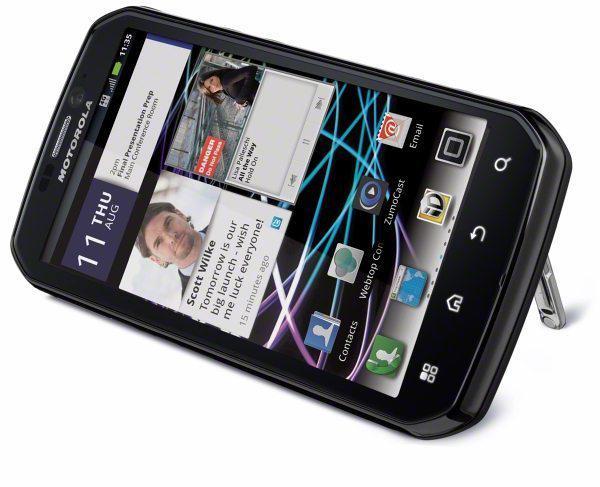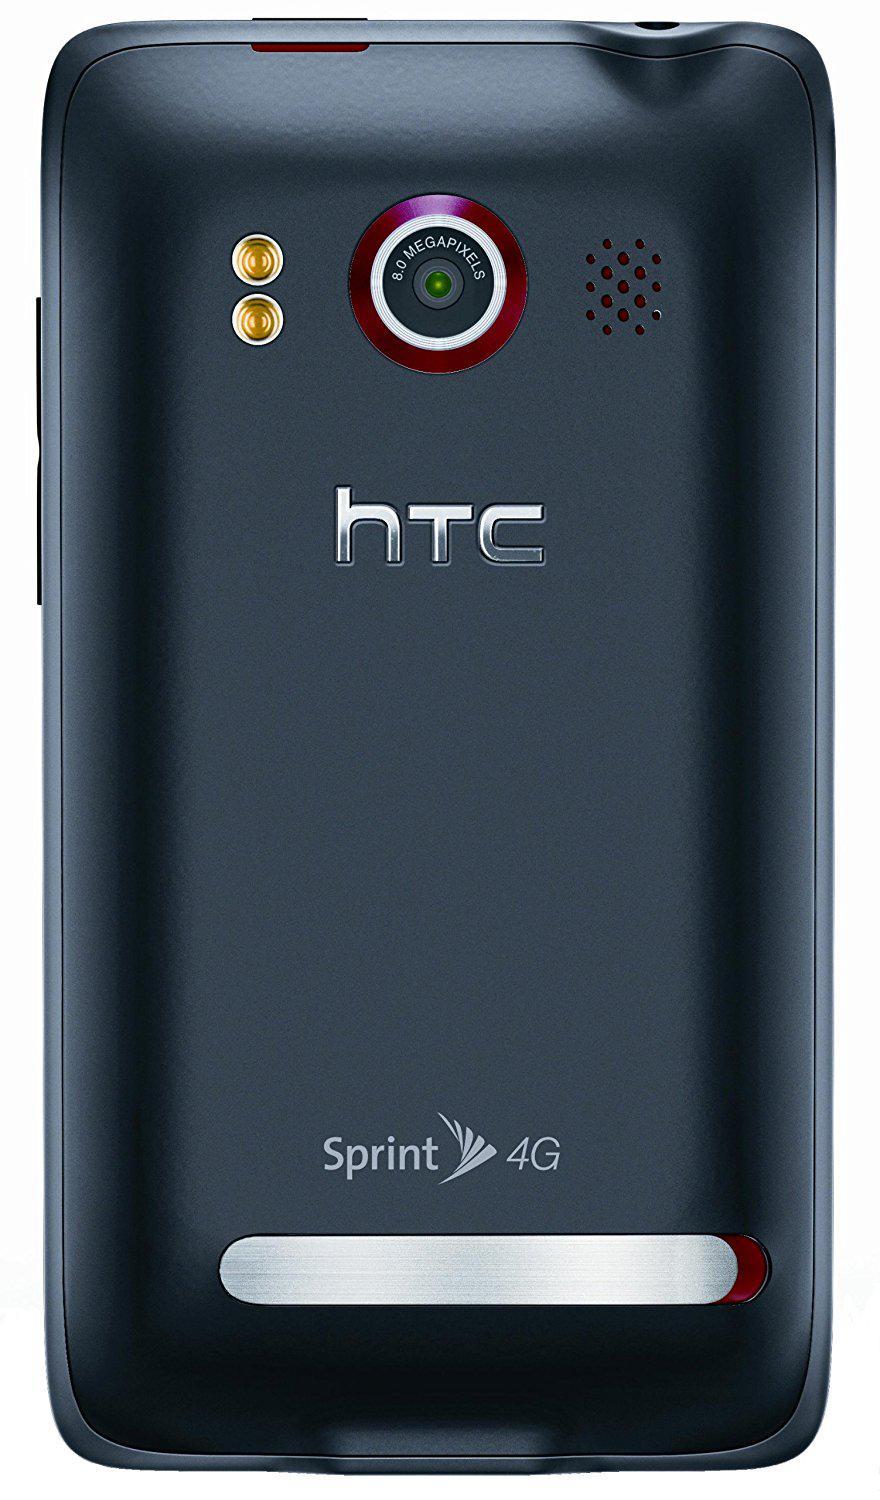The first image is the image on the left, the second image is the image on the right. Given the left and right images, does the statement "All phones are shown upright, and none of them have physical keyboards." hold true? Answer yes or no. No. The first image is the image on the left, the second image is the image on the right. For the images displayed, is the sentence "All devices are rectangular and displayed vertically, and at least one device has geometric shapes of different colors filling its screen." factually correct? Answer yes or no. No. 